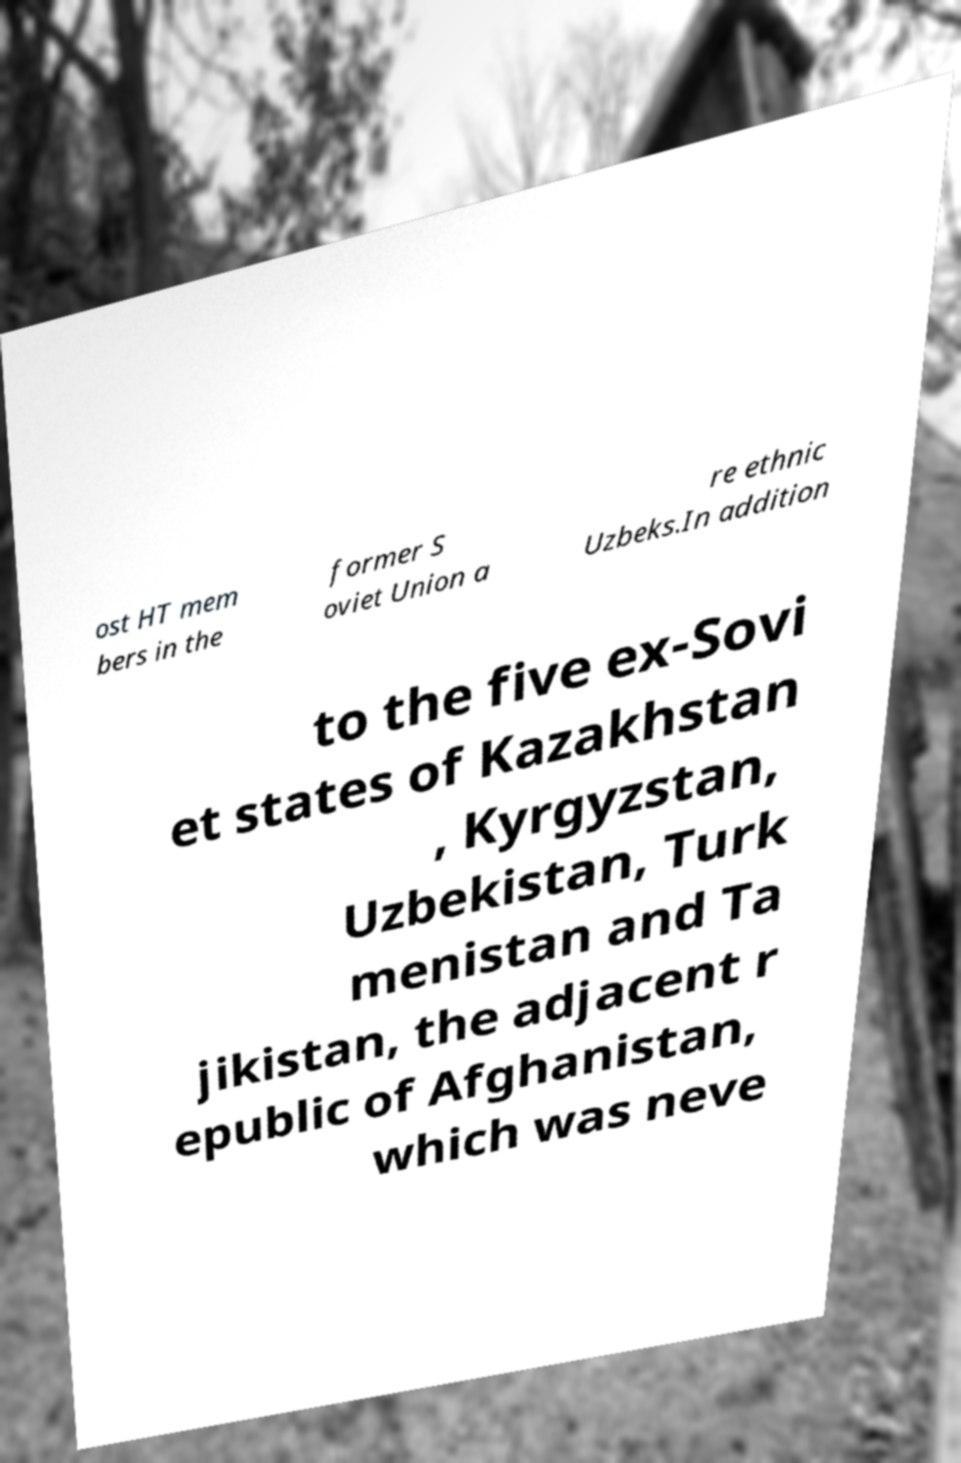Could you assist in decoding the text presented in this image and type it out clearly? ost HT mem bers in the former S oviet Union a re ethnic Uzbeks.In addition to the five ex-Sovi et states of Kazakhstan , Kyrgyzstan, Uzbekistan, Turk menistan and Ta jikistan, the adjacent r epublic of Afghanistan, which was neve 